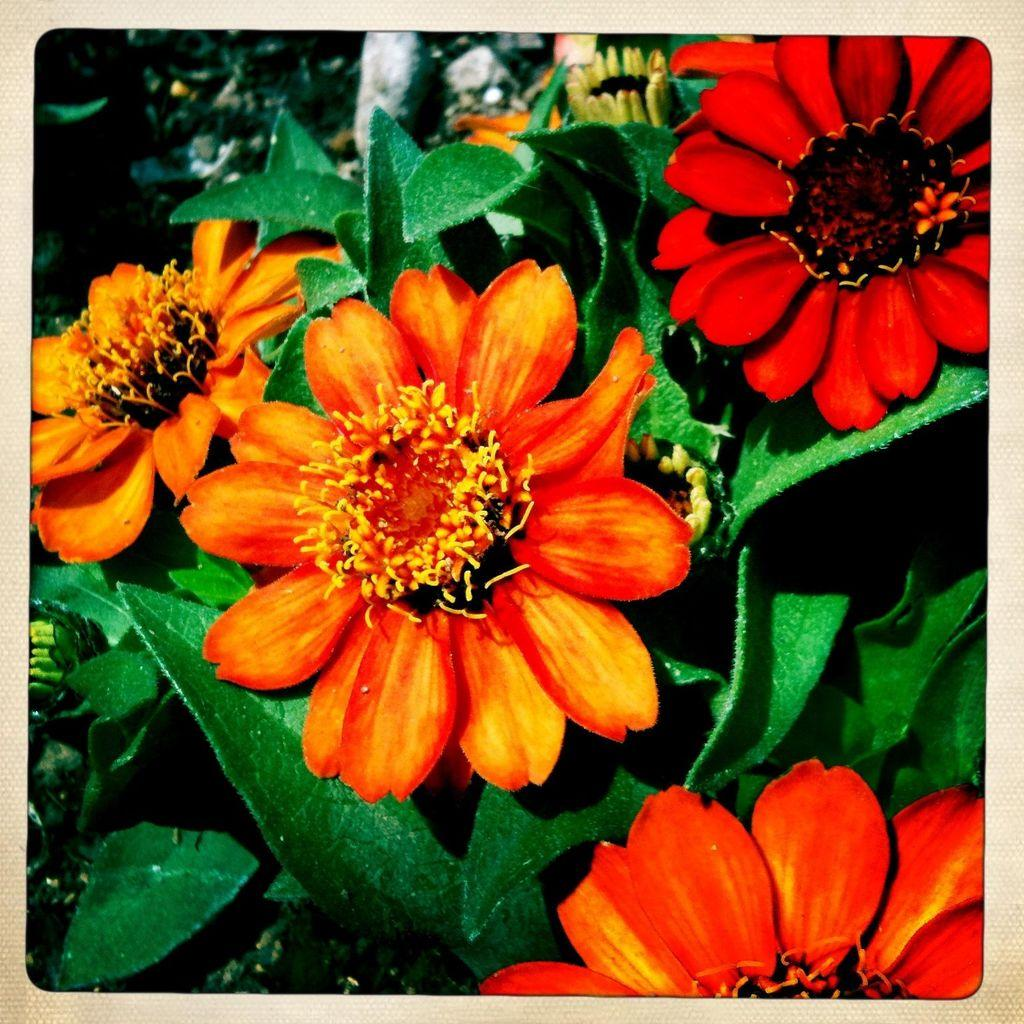Where was the image taken? The image is taken outdoors. What can be seen in the image besides the outdoor setting? There is a plant in the image. What are the characteristics of the plant? The plant has green leaves and flowers. What color are the flowers on the plant? The flowers are orange in color. Is there a snail crawling on the plant in the image? There is no snail visible in the image. Who is serving the drink to the person in the image? There is no person or drink present in the image. 